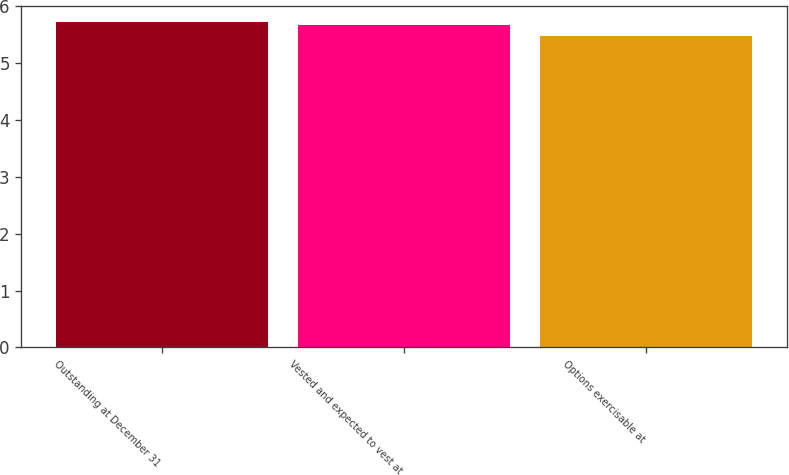Convert chart to OTSL. <chart><loc_0><loc_0><loc_500><loc_500><bar_chart><fcel>Outstanding at December 31<fcel>Vested and expected to vest at<fcel>Options exercisable at<nl><fcel>5.72<fcel>5.68<fcel>5.48<nl></chart> 